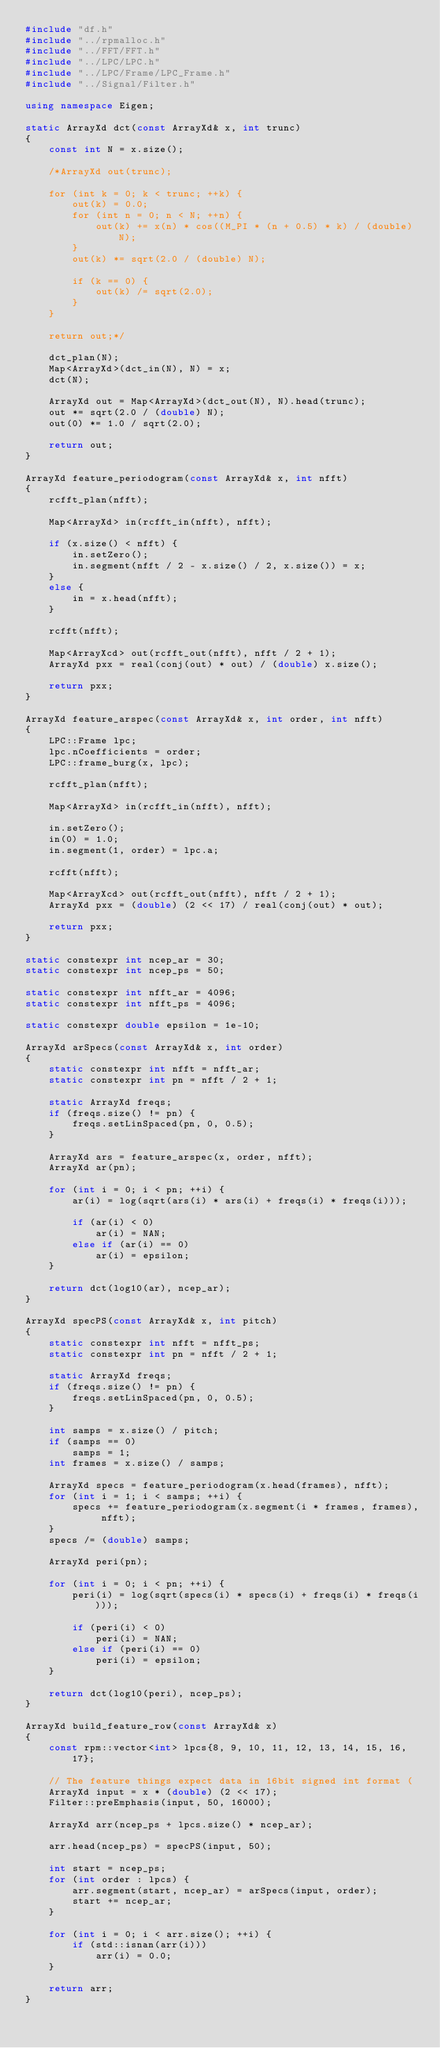<code> <loc_0><loc_0><loc_500><loc_500><_C++_>#include "df.h"
#include "../rpmalloc.h"
#include "../FFT/FFT.h"
#include "../LPC/LPC.h"
#include "../LPC/Frame/LPC_Frame.h"
#include "../Signal/Filter.h"

using namespace Eigen;

static ArrayXd dct(const ArrayXd& x, int trunc)
{
    const int N = x.size();
    
    /*ArrayXd out(trunc);

    for (int k = 0; k < trunc; ++k) {
        out(k) = 0.0;
        for (int n = 0; n < N; ++n) {
            out(k) += x(n) * cos((M_PI * (n + 0.5) * k) / (double) N);
        }
        out(k) *= sqrt(2.0 / (double) N);
        
        if (k == 0) {
            out(k) /= sqrt(2.0);
        }
    }

    return out;*/

    dct_plan(N);
    Map<ArrayXd>(dct_in(N), N) = x;
    dct(N);
    
    ArrayXd out = Map<ArrayXd>(dct_out(N), N).head(trunc);
    out *= sqrt(2.0 / (double) N);
    out(0) *= 1.0 / sqrt(2.0);

    return out;
} 

ArrayXd feature_periodogram(const ArrayXd& x, int nfft)
{
    rcfft_plan(nfft);

    Map<ArrayXd> in(rcfft_in(nfft), nfft);
   
    if (x.size() < nfft) {
        in.setZero();
        in.segment(nfft / 2 - x.size() / 2, x.size()) = x;
    }
    else {
        in = x.head(nfft);
    }

    rcfft(nfft);

    Map<ArrayXcd> out(rcfft_out(nfft), nfft / 2 + 1);
    ArrayXd pxx = real(conj(out) * out) / (double) x.size();

    return pxx;
}

ArrayXd feature_arspec(const ArrayXd& x, int order, int nfft)
{
    LPC::Frame lpc;
    lpc.nCoefficients = order;
    LPC::frame_burg(x, lpc);

    rcfft_plan(nfft);

    Map<ArrayXd> in(rcfft_in(nfft), nfft);
   
    in.setZero();
    in(0) = 1.0;
    in.segment(1, order) = lpc.a;
    
    rcfft(nfft);

    Map<ArrayXcd> out(rcfft_out(nfft), nfft / 2 + 1);
    ArrayXd pxx = (double) (2 << 17) / real(conj(out) * out);

    return pxx;
}

static constexpr int ncep_ar = 30;
static constexpr int ncep_ps = 50;

static constexpr int nfft_ar = 4096;
static constexpr int nfft_ps = 4096;

static constexpr double epsilon = 1e-10;

ArrayXd arSpecs(const ArrayXd& x, int order)
{
    static constexpr int nfft = nfft_ar;
    static constexpr int pn = nfft / 2 + 1;

    static ArrayXd freqs;
    if (freqs.size() != pn) {
        freqs.setLinSpaced(pn, 0, 0.5);
    }

    ArrayXd ars = feature_arspec(x, order, nfft);
    ArrayXd ar(pn);

    for (int i = 0; i < pn; ++i) {
        ar(i) = log(sqrt(ars(i) * ars(i) + freqs(i) * freqs(i)));

        if (ar(i) < 0)
            ar(i) = NAN;
        else if (ar(i) == 0)
            ar(i) = epsilon;
    }
   
    return dct(log10(ar), ncep_ar);
}

ArrayXd specPS(const ArrayXd& x, int pitch)
{
    static constexpr int nfft = nfft_ps;
    static constexpr int pn = nfft / 2 + 1;

    static ArrayXd freqs;
    if (freqs.size() != pn) {
        freqs.setLinSpaced(pn, 0, 0.5);
    }

    int samps = x.size() / pitch;
    if (samps == 0)
        samps = 1;
    int frames = x.size() / samps;

    ArrayXd specs = feature_periodogram(x.head(frames), nfft);
    for (int i = 1; i < samps; ++i) {
        specs += feature_periodogram(x.segment(i * frames, frames), nfft);
    }
    specs /= (double) samps;

    ArrayXd peri(pn);

    for (int i = 0; i < pn; ++i) {
        peri(i) = log(sqrt(specs(i) * specs(i) + freqs(i) * freqs(i)));

        if (peri(i) < 0)
            peri(i) = NAN;
        else if (peri(i) == 0)
            peri(i) = epsilon;
    }
   
    return dct(log10(peri), ncep_ps);
}

ArrayXd build_feature_row(const ArrayXd& x)
{
    const rpm::vector<int> lpcs{8, 9, 10, 11, 12, 13, 14, 15, 16, 17};
    
    // The feature things expect data in 16bit signed int format (
    ArrayXd input = x * (double) (2 << 17);
    Filter::preEmphasis(input, 50, 16000);
    
    ArrayXd arr(ncep_ps + lpcs.size() * ncep_ar);

    arr.head(ncep_ps) = specPS(input, 50);

    int start = ncep_ps;
    for (int order : lpcs) {
        arr.segment(start, ncep_ar) = arSpecs(input, order);
        start += ncep_ar;
    }

    for (int i = 0; i < arr.size(); ++i) {
        if (std::isnan(arr(i)))
            arr(i) = 0.0;
    }

    return arr;
}
</code> 